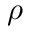<formula> <loc_0><loc_0><loc_500><loc_500>\rho</formula> 